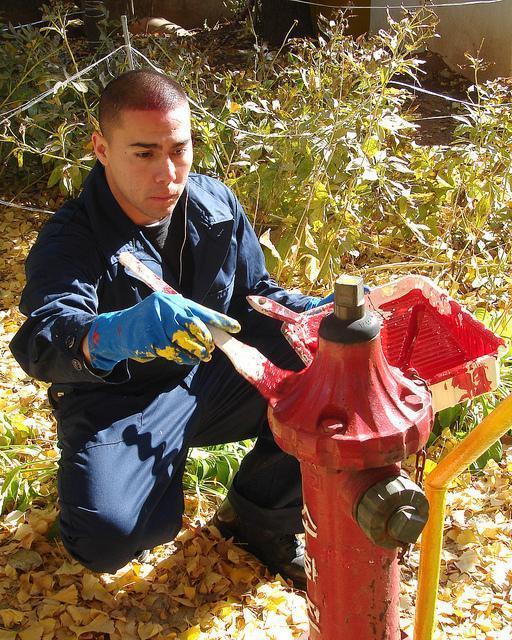How many oranges with barcode stickers?
Give a very brief answer. 0. 